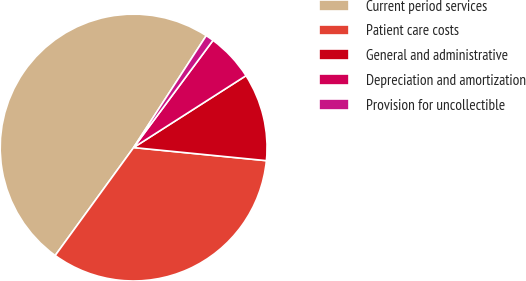Convert chart. <chart><loc_0><loc_0><loc_500><loc_500><pie_chart><fcel>Current period services<fcel>Patient care costs<fcel>General and administrative<fcel>Depreciation and amortization<fcel>Provision for uncollectible<nl><fcel>49.16%<fcel>33.43%<fcel>10.62%<fcel>5.8%<fcel>0.98%<nl></chart> 